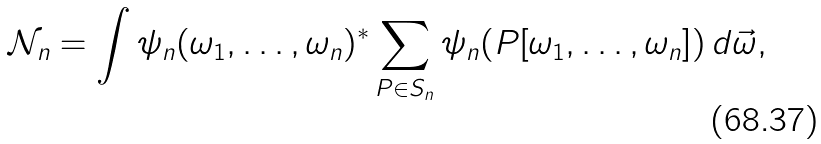Convert formula to latex. <formula><loc_0><loc_0><loc_500><loc_500>\mathcal { N } _ { n } = \int \psi _ { n } ( \omega _ { 1 } , \dots , \omega _ { n } ) ^ { * } \sum _ { P \in S _ { n } } \psi _ { n } ( P [ \omega _ { 1 } , \dots , \omega _ { n } ] ) \, d \vec { \omega } ,</formula> 